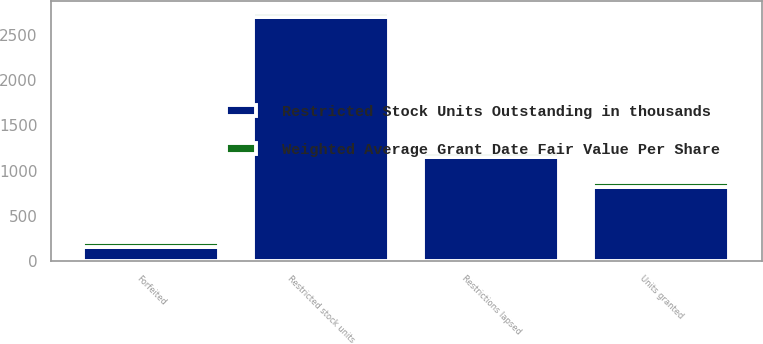Convert chart. <chart><loc_0><loc_0><loc_500><loc_500><stacked_bar_chart><ecel><fcel>Restricted stock units<fcel>Units granted<fcel>Restrictions lapsed<fcel>Forfeited<nl><fcel>Restricted Stock Units Outstanding in thousands<fcel>2698<fcel>818<fcel>1151<fcel>157<nl><fcel>Weighted Average Grant Date Fair Value Per Share<fcel>47.59<fcel>52.25<fcel>39.72<fcel>45.8<nl></chart> 